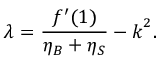Convert formula to latex. <formula><loc_0><loc_0><loc_500><loc_500>\lambda = \frac { f ^ { \prime } ( 1 ) } { \eta _ { B } + \eta _ { S } } - k ^ { 2 } .</formula> 